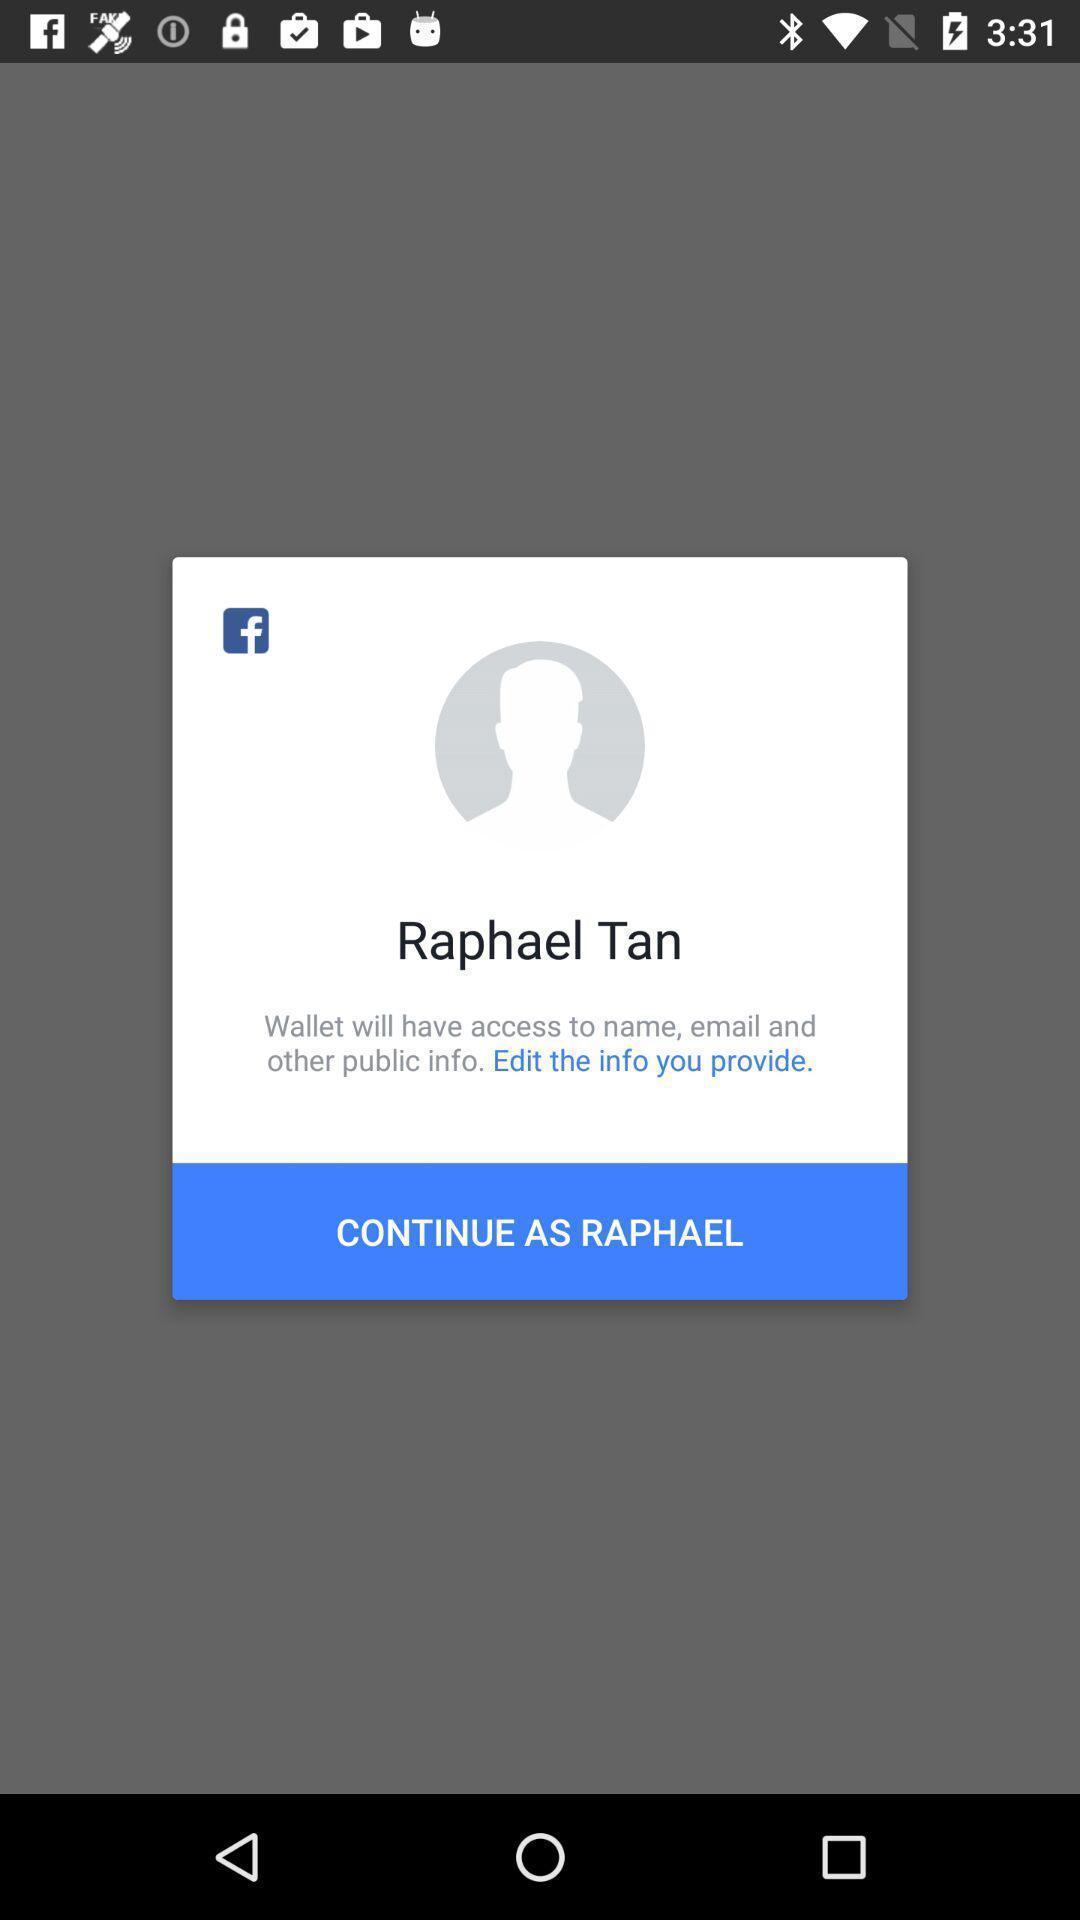Explain the elements present in this screenshot. Pop up showing social networking application. 